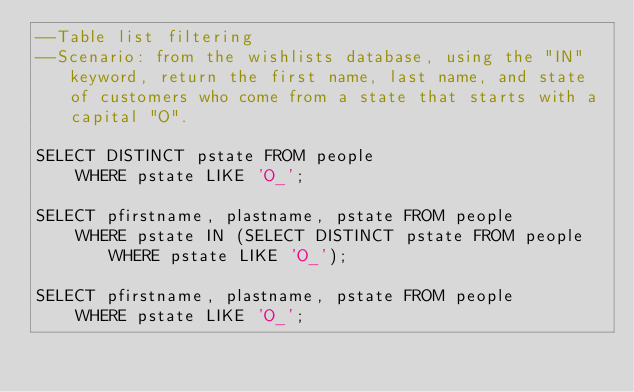Convert code to text. <code><loc_0><loc_0><loc_500><loc_500><_SQL_>--Table list filtering 
--Scenario: from the wishlists database, using the "IN" keyword, return the first name, last name, and state of customers who come from a state that starts with a capital "O".

SELECT DISTINCT pstate FROM people
	WHERE pstate LIKE 'O_';

SELECT pfirstname, plastname, pstate FROM people
	WHERE pstate IN (SELECT DISTINCT pstate FROM people WHERE pstate LIKE 'O_');

SELECT pfirstname, plastname, pstate FROM people
	WHERE pstate LIKE 'O_';</code> 